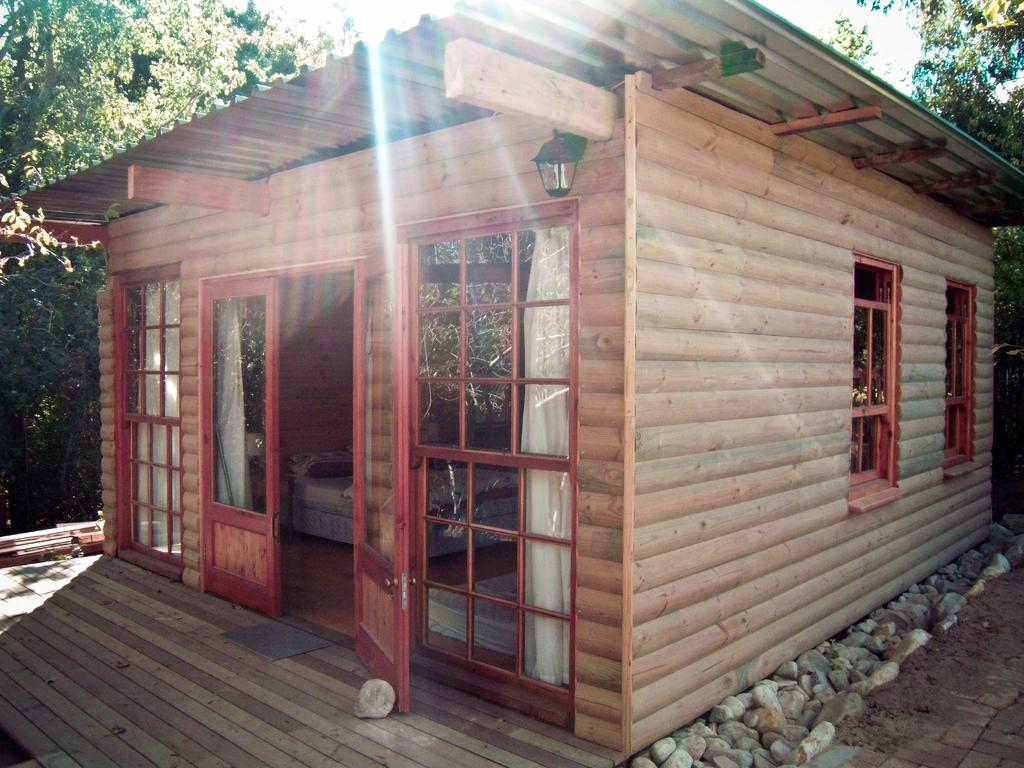What is located in the center of the picture? In the center of the picture, there are stones, windows, a door, a curtain, a bed, and a light. What type of structure is depicted in the image? The scene is set in a house. What can be seen in the background of the picture? There are trees in the background of the picture. What is the weather like in the image? The weather is sunny. What type of brush is being used to paint the lace in the image? There is no brush or lace present in the image; the scene is set in a house with a bed, windows, a door, a curtain, a light, and stones in the center of the picture. 